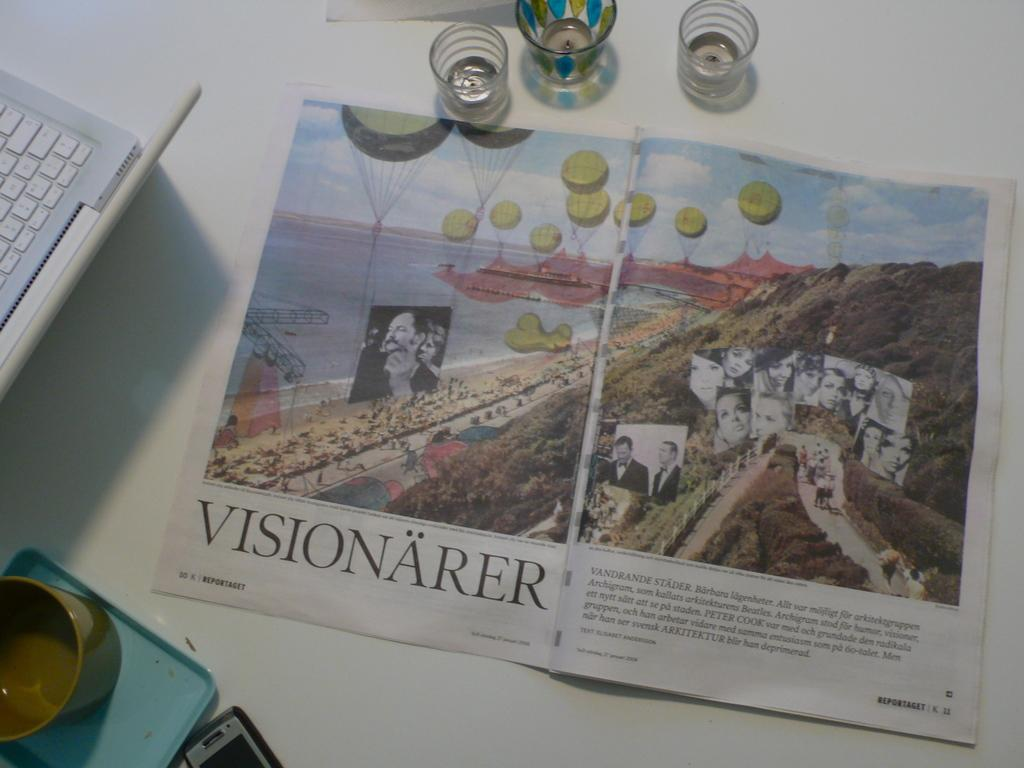<image>
Present a compact description of the photo's key features. A magazine is open to a picture of a shoreline with the title Visionarer. 